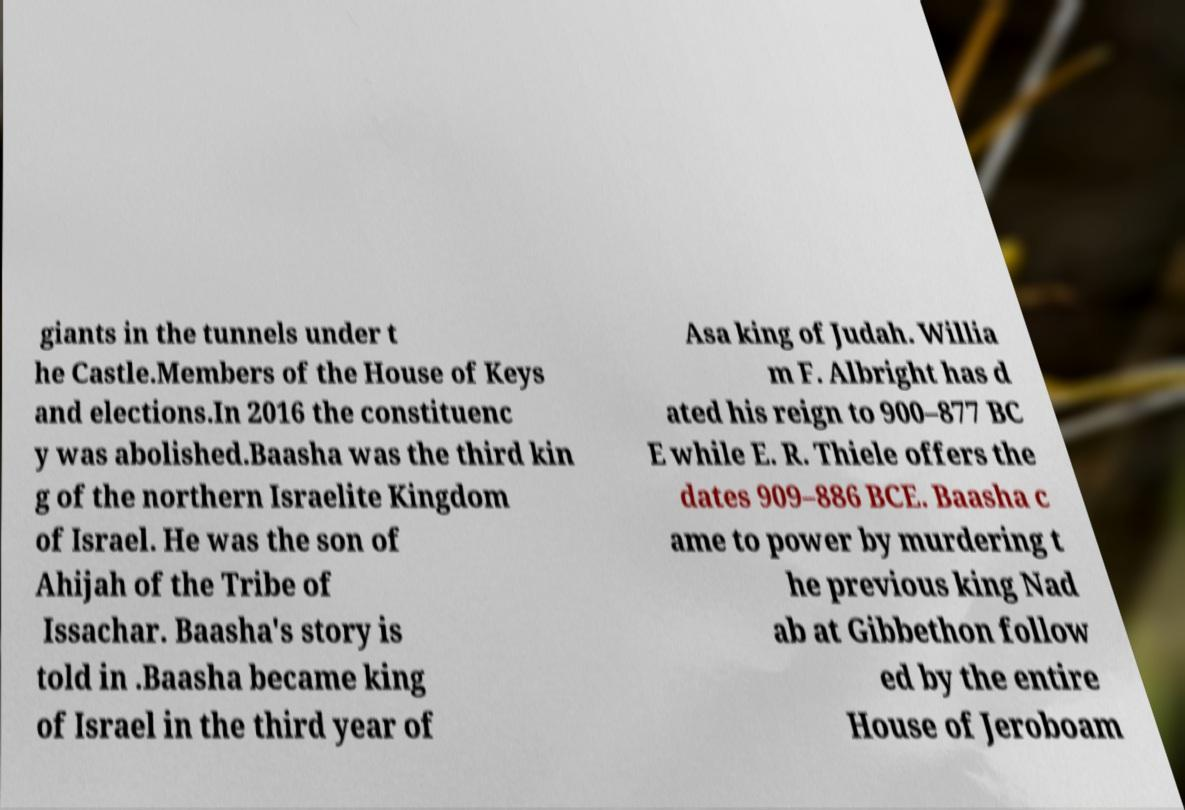Could you extract and type out the text from this image? giants in the tunnels under t he Castle.Members of the House of Keys and elections.In 2016 the constituenc y was abolished.Baasha was the third kin g of the northern Israelite Kingdom of Israel. He was the son of Ahijah of the Tribe of Issachar. Baasha's story is told in .Baasha became king of Israel in the third year of Asa king of Judah. Willia m F. Albright has d ated his reign to 900–877 BC E while E. R. Thiele offers the dates 909–886 BCE. Baasha c ame to power by murdering t he previous king Nad ab at Gibbethon follow ed by the entire House of Jeroboam 